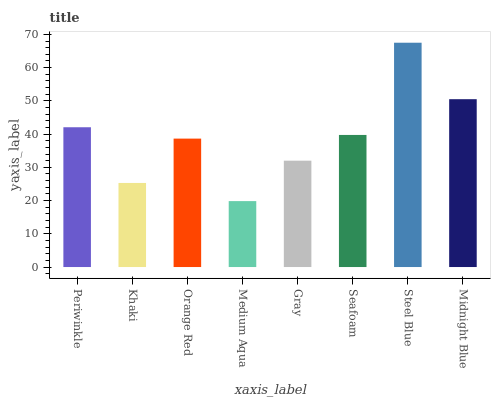Is Medium Aqua the minimum?
Answer yes or no. Yes. Is Steel Blue the maximum?
Answer yes or no. Yes. Is Khaki the minimum?
Answer yes or no. No. Is Khaki the maximum?
Answer yes or no. No. Is Periwinkle greater than Khaki?
Answer yes or no. Yes. Is Khaki less than Periwinkle?
Answer yes or no. Yes. Is Khaki greater than Periwinkle?
Answer yes or no. No. Is Periwinkle less than Khaki?
Answer yes or no. No. Is Seafoam the high median?
Answer yes or no. Yes. Is Orange Red the low median?
Answer yes or no. Yes. Is Gray the high median?
Answer yes or no. No. Is Seafoam the low median?
Answer yes or no. No. 